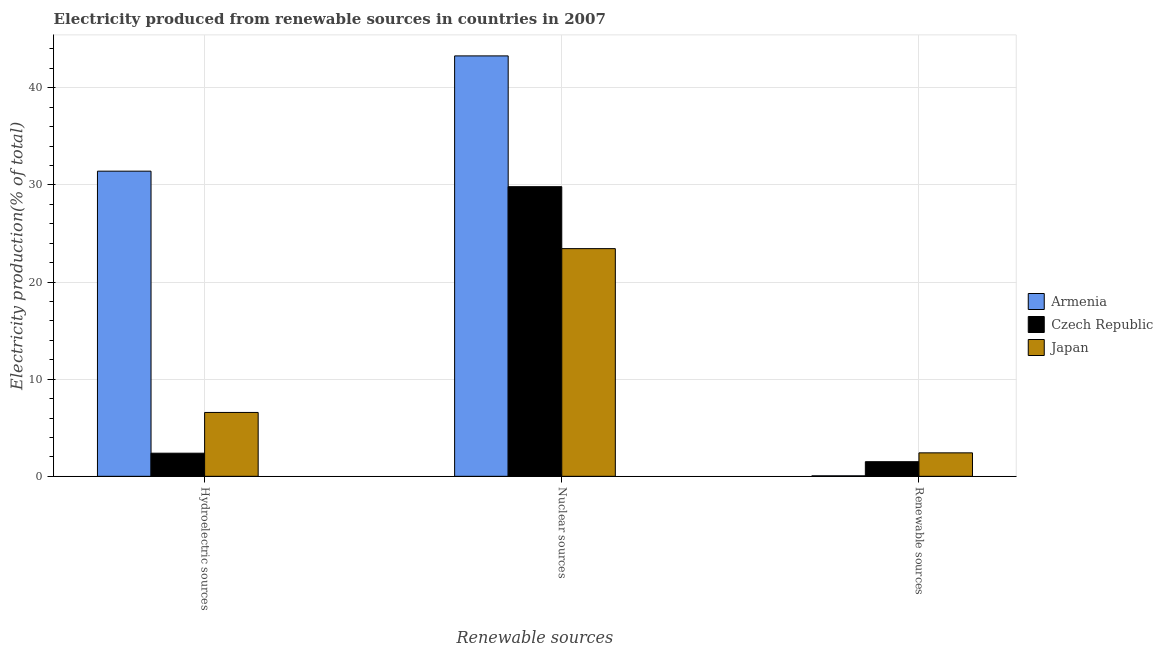Are the number of bars per tick equal to the number of legend labels?
Your response must be concise. Yes. Are the number of bars on each tick of the X-axis equal?
Your answer should be compact. Yes. How many bars are there on the 1st tick from the right?
Give a very brief answer. 3. What is the label of the 3rd group of bars from the left?
Offer a very short reply. Renewable sources. What is the percentage of electricity produced by renewable sources in Armenia?
Your answer should be very brief. 0.05. Across all countries, what is the maximum percentage of electricity produced by hydroelectric sources?
Make the answer very short. 31.42. Across all countries, what is the minimum percentage of electricity produced by renewable sources?
Offer a terse response. 0.05. In which country was the percentage of electricity produced by hydroelectric sources maximum?
Provide a succinct answer. Armenia. In which country was the percentage of electricity produced by nuclear sources minimum?
Make the answer very short. Japan. What is the total percentage of electricity produced by nuclear sources in the graph?
Keep it short and to the point. 96.55. What is the difference between the percentage of electricity produced by nuclear sources in Armenia and that in Japan?
Keep it short and to the point. 19.84. What is the difference between the percentage of electricity produced by renewable sources in Czech Republic and the percentage of electricity produced by nuclear sources in Armenia?
Provide a succinct answer. -41.78. What is the average percentage of electricity produced by hydroelectric sources per country?
Offer a very short reply. 13.46. What is the difference between the percentage of electricity produced by renewable sources and percentage of electricity produced by hydroelectric sources in Czech Republic?
Your answer should be very brief. -0.88. In how many countries, is the percentage of electricity produced by nuclear sources greater than 24 %?
Provide a short and direct response. 2. What is the ratio of the percentage of electricity produced by hydroelectric sources in Japan to that in Armenia?
Your response must be concise. 0.21. Is the percentage of electricity produced by hydroelectric sources in Czech Republic less than that in Japan?
Your answer should be compact. Yes. What is the difference between the highest and the second highest percentage of electricity produced by hydroelectric sources?
Ensure brevity in your answer.  24.84. What is the difference between the highest and the lowest percentage of electricity produced by hydroelectric sources?
Offer a very short reply. 29.04. In how many countries, is the percentage of electricity produced by renewable sources greater than the average percentage of electricity produced by renewable sources taken over all countries?
Give a very brief answer. 2. Is the sum of the percentage of electricity produced by hydroelectric sources in Czech Republic and Japan greater than the maximum percentage of electricity produced by nuclear sources across all countries?
Ensure brevity in your answer.  No. What does the 1st bar from the left in Nuclear sources represents?
Provide a short and direct response. Armenia. What does the 1st bar from the right in Nuclear sources represents?
Your answer should be compact. Japan. Is it the case that in every country, the sum of the percentage of electricity produced by hydroelectric sources and percentage of electricity produced by nuclear sources is greater than the percentage of electricity produced by renewable sources?
Offer a terse response. Yes. Are all the bars in the graph horizontal?
Your answer should be very brief. No. What is the difference between two consecutive major ticks on the Y-axis?
Your response must be concise. 10. Where does the legend appear in the graph?
Make the answer very short. Center right. How many legend labels are there?
Give a very brief answer. 3. What is the title of the graph?
Your answer should be very brief. Electricity produced from renewable sources in countries in 2007. What is the label or title of the X-axis?
Offer a very short reply. Renewable sources. What is the Electricity production(% of total) in Armenia in Hydroelectric sources?
Offer a terse response. 31.42. What is the Electricity production(% of total) of Czech Republic in Hydroelectric sources?
Provide a succinct answer. 2.38. What is the Electricity production(% of total) of Japan in Hydroelectric sources?
Give a very brief answer. 6.58. What is the Electricity production(% of total) of Armenia in Nuclear sources?
Your answer should be very brief. 43.29. What is the Electricity production(% of total) in Czech Republic in Nuclear sources?
Provide a succinct answer. 29.82. What is the Electricity production(% of total) in Japan in Nuclear sources?
Your answer should be compact. 23.44. What is the Electricity production(% of total) in Armenia in Renewable sources?
Provide a succinct answer. 0.05. What is the Electricity production(% of total) of Czech Republic in Renewable sources?
Your answer should be very brief. 1.51. What is the Electricity production(% of total) of Japan in Renewable sources?
Provide a short and direct response. 2.42. Across all Renewable sources, what is the maximum Electricity production(% of total) in Armenia?
Provide a short and direct response. 43.29. Across all Renewable sources, what is the maximum Electricity production(% of total) in Czech Republic?
Give a very brief answer. 29.82. Across all Renewable sources, what is the maximum Electricity production(% of total) of Japan?
Offer a very short reply. 23.44. Across all Renewable sources, what is the minimum Electricity production(% of total) in Armenia?
Your response must be concise. 0.05. Across all Renewable sources, what is the minimum Electricity production(% of total) of Czech Republic?
Your answer should be very brief. 1.51. Across all Renewable sources, what is the minimum Electricity production(% of total) in Japan?
Offer a very short reply. 2.42. What is the total Electricity production(% of total) of Armenia in the graph?
Offer a terse response. 74.75. What is the total Electricity production(% of total) of Czech Republic in the graph?
Provide a short and direct response. 33.71. What is the total Electricity production(% of total) in Japan in the graph?
Provide a succinct answer. 32.43. What is the difference between the Electricity production(% of total) of Armenia in Hydroelectric sources and that in Nuclear sources?
Give a very brief answer. -11.87. What is the difference between the Electricity production(% of total) of Czech Republic in Hydroelectric sources and that in Nuclear sources?
Your response must be concise. -27.44. What is the difference between the Electricity production(% of total) of Japan in Hydroelectric sources and that in Nuclear sources?
Make the answer very short. -16.87. What is the difference between the Electricity production(% of total) in Armenia in Hydroelectric sources and that in Renewable sources?
Provide a short and direct response. 31.37. What is the difference between the Electricity production(% of total) of Czech Republic in Hydroelectric sources and that in Renewable sources?
Keep it short and to the point. 0.88. What is the difference between the Electricity production(% of total) of Japan in Hydroelectric sources and that in Renewable sources?
Provide a short and direct response. 4.16. What is the difference between the Electricity production(% of total) in Armenia in Nuclear sources and that in Renewable sources?
Ensure brevity in your answer.  43.23. What is the difference between the Electricity production(% of total) in Czech Republic in Nuclear sources and that in Renewable sources?
Your response must be concise. 28.32. What is the difference between the Electricity production(% of total) in Japan in Nuclear sources and that in Renewable sources?
Give a very brief answer. 21.03. What is the difference between the Electricity production(% of total) in Armenia in Hydroelectric sources and the Electricity production(% of total) in Czech Republic in Nuclear sources?
Provide a succinct answer. 1.6. What is the difference between the Electricity production(% of total) in Armenia in Hydroelectric sources and the Electricity production(% of total) in Japan in Nuclear sources?
Ensure brevity in your answer.  7.98. What is the difference between the Electricity production(% of total) of Czech Republic in Hydroelectric sources and the Electricity production(% of total) of Japan in Nuclear sources?
Provide a succinct answer. -21.06. What is the difference between the Electricity production(% of total) of Armenia in Hydroelectric sources and the Electricity production(% of total) of Czech Republic in Renewable sources?
Keep it short and to the point. 29.91. What is the difference between the Electricity production(% of total) in Armenia in Hydroelectric sources and the Electricity production(% of total) in Japan in Renewable sources?
Ensure brevity in your answer.  29. What is the difference between the Electricity production(% of total) of Czech Republic in Hydroelectric sources and the Electricity production(% of total) of Japan in Renewable sources?
Offer a terse response. -0.04. What is the difference between the Electricity production(% of total) of Armenia in Nuclear sources and the Electricity production(% of total) of Czech Republic in Renewable sources?
Provide a succinct answer. 41.78. What is the difference between the Electricity production(% of total) of Armenia in Nuclear sources and the Electricity production(% of total) of Japan in Renewable sources?
Provide a short and direct response. 40.87. What is the difference between the Electricity production(% of total) of Czech Republic in Nuclear sources and the Electricity production(% of total) of Japan in Renewable sources?
Offer a terse response. 27.4. What is the average Electricity production(% of total) of Armenia per Renewable sources?
Ensure brevity in your answer.  24.92. What is the average Electricity production(% of total) of Czech Republic per Renewable sources?
Ensure brevity in your answer.  11.24. What is the average Electricity production(% of total) of Japan per Renewable sources?
Your response must be concise. 10.81. What is the difference between the Electricity production(% of total) in Armenia and Electricity production(% of total) in Czech Republic in Hydroelectric sources?
Make the answer very short. 29.04. What is the difference between the Electricity production(% of total) of Armenia and Electricity production(% of total) of Japan in Hydroelectric sources?
Provide a short and direct response. 24.84. What is the difference between the Electricity production(% of total) of Czech Republic and Electricity production(% of total) of Japan in Hydroelectric sources?
Your answer should be very brief. -4.2. What is the difference between the Electricity production(% of total) in Armenia and Electricity production(% of total) in Czech Republic in Nuclear sources?
Offer a terse response. 13.46. What is the difference between the Electricity production(% of total) of Armenia and Electricity production(% of total) of Japan in Nuclear sources?
Make the answer very short. 19.84. What is the difference between the Electricity production(% of total) in Czech Republic and Electricity production(% of total) in Japan in Nuclear sources?
Provide a succinct answer. 6.38. What is the difference between the Electricity production(% of total) in Armenia and Electricity production(% of total) in Czech Republic in Renewable sources?
Your response must be concise. -1.45. What is the difference between the Electricity production(% of total) of Armenia and Electricity production(% of total) of Japan in Renewable sources?
Keep it short and to the point. -2.37. What is the difference between the Electricity production(% of total) in Czech Republic and Electricity production(% of total) in Japan in Renewable sources?
Provide a short and direct response. -0.91. What is the ratio of the Electricity production(% of total) in Armenia in Hydroelectric sources to that in Nuclear sources?
Provide a succinct answer. 0.73. What is the ratio of the Electricity production(% of total) in Czech Republic in Hydroelectric sources to that in Nuclear sources?
Offer a terse response. 0.08. What is the ratio of the Electricity production(% of total) of Japan in Hydroelectric sources to that in Nuclear sources?
Offer a terse response. 0.28. What is the ratio of the Electricity production(% of total) of Armenia in Hydroelectric sources to that in Renewable sources?
Ensure brevity in your answer.  617.67. What is the ratio of the Electricity production(% of total) of Czech Republic in Hydroelectric sources to that in Renewable sources?
Make the answer very short. 1.58. What is the ratio of the Electricity production(% of total) of Japan in Hydroelectric sources to that in Renewable sources?
Keep it short and to the point. 2.72. What is the ratio of the Electricity production(% of total) in Armenia in Nuclear sources to that in Renewable sources?
Ensure brevity in your answer.  851. What is the ratio of the Electricity production(% of total) of Czech Republic in Nuclear sources to that in Renewable sources?
Make the answer very short. 19.81. What is the ratio of the Electricity production(% of total) of Japan in Nuclear sources to that in Renewable sources?
Provide a short and direct response. 9.7. What is the difference between the highest and the second highest Electricity production(% of total) in Armenia?
Give a very brief answer. 11.87. What is the difference between the highest and the second highest Electricity production(% of total) in Czech Republic?
Provide a short and direct response. 27.44. What is the difference between the highest and the second highest Electricity production(% of total) in Japan?
Offer a terse response. 16.87. What is the difference between the highest and the lowest Electricity production(% of total) of Armenia?
Keep it short and to the point. 43.23. What is the difference between the highest and the lowest Electricity production(% of total) of Czech Republic?
Give a very brief answer. 28.32. What is the difference between the highest and the lowest Electricity production(% of total) of Japan?
Offer a terse response. 21.03. 